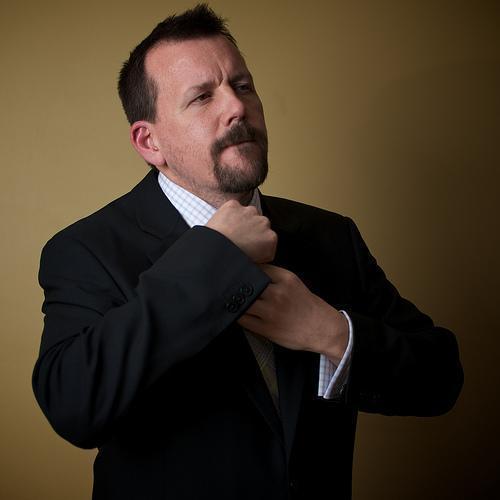How many people can be seen?
Give a very brief answer. 1. How many buttons is on the man's right sleeve?
Give a very brief answer. 3. 